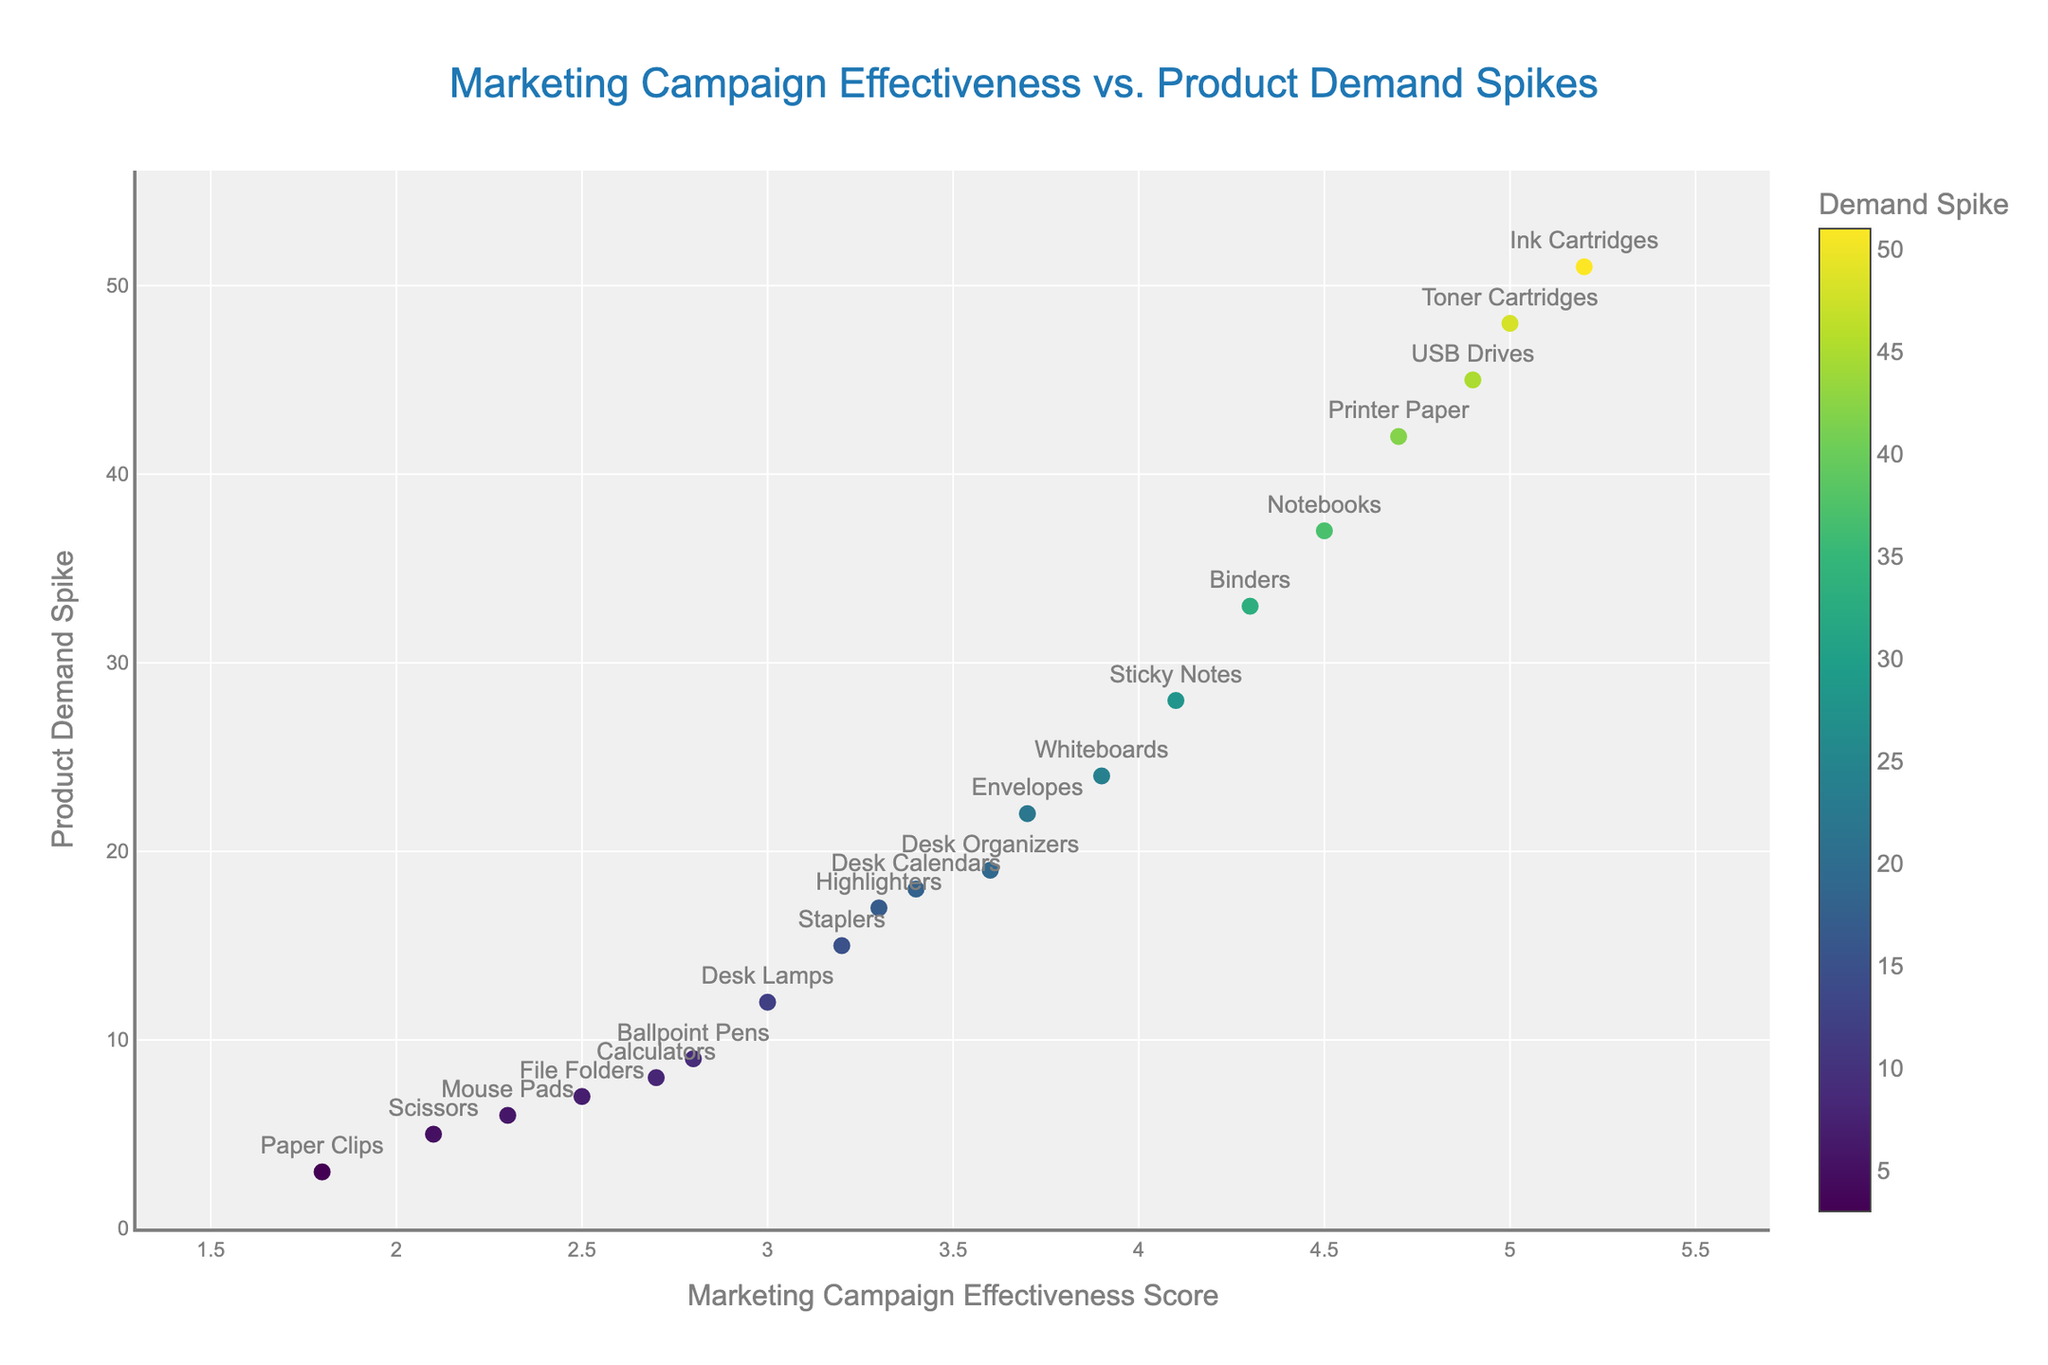what's the title of the figure? The title is centrally located at the top of the figure. The text reads "Marketing Campaign Effectiveness vs. Product Demand Spikes".
Answer: Marketing Campaign Effectiveness vs. Product Demand Spikes What products have the highest marketing campaign effectiveness score? To determine this, locate the highest values on the x-axis which denotes the marketing campaign effectiveness score. The products with the highest scores are at the far right of the plot.
Answer: USB Drives, Toner Cartridges, Ink Cartridges What's the demand spike value for Staplers? Find Staplers on the plot (labels are shown), then check the y-axis value corresponding to Staplers. The demand spike is located a little above 15.
Answer: 15 Which product has the least demand spike? To answer this, identify the data point with the lowest position along the y-axis, as this axis represents the demand spike. Paper Clips, located near the bottom, has the least demand spike.
Answer: Paper Clips Are products with higher marketing scores generally having higher demand spikes? To answer this, observe the trend of data points from the left (low marketing score) to the right (high marketing score). Note if data points tend to move higher along the y-axis.
Answer: Yes Which product has a demand spike closest to 30? Find the y-axis value around 30, then check which product's data point aligns closest to this value. Sticky Notes, whose demand spike is 28, is closest to this value.
Answer: Sticky Notes What is the average marketing score of products with a demand spike greater than 40? First, identify products with a demand spike greater than 40 (such as USB Drives, Toner Cartridges, Ink Cartridges, Printer Paper). Then, sum their marketing scores and divide by the number of these products (4.9 + 5.0 + 5.2 + 4.7) / 4.
Answer: 4.95 Which product has a higher demand spike, Notebooks or Desk Organizers? Locate both products on the plot. Compare their positions on the y-axis (demand spike). Notebooks are higher than Desk Organizers.
Answer: Notebooks What's the average demand spike of all products shown? Sum the demand spike values of all products and divide by the total number of products. (15 + 42 + 9 + 28 + 19 + 51 + 7 + 24 + 3 + 17 + 5 + 22 + 33 + 12 + 8 + 37 + 45 + 6 + 48 + 18) / 20 = 470 / 20
Answer: 23.5 Which products have both high marketing scores (above 4.5) and high demand spikes (above 40)? Identify products meeting both criteria: high marketing score above 4.5 and demand spike above 40. These products are USB Drives, Toner Cartridges, and Ink Cartridges.
Answer: USB Drives, Toner Cartridges, Ink Cartridges 